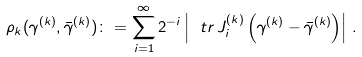<formula> <loc_0><loc_0><loc_500><loc_500>\rho _ { k } ( \gamma ^ { ( k ) } , \bar { \gamma } ^ { ( k ) } ) \colon = \sum _ { i = 1 } ^ { \infty } 2 ^ { - i } \left | \ t r \, J ^ { ( k ) } _ { i } \left ( \gamma ^ { ( k ) } - \bar { \gamma } ^ { ( k ) } \right ) \right | \, .</formula> 